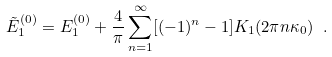Convert formula to latex. <formula><loc_0><loc_0><loc_500><loc_500>\tilde { E } _ { 1 } ^ { ( 0 ) } = E _ { 1 } ^ { ( 0 ) } + \frac { 4 } { \pi } \sum _ { n = 1 } ^ { \infty } [ ( - 1 ) ^ { n } - 1 ] K _ { 1 } ( 2 \pi n \kappa _ { 0 } ) \ .</formula> 